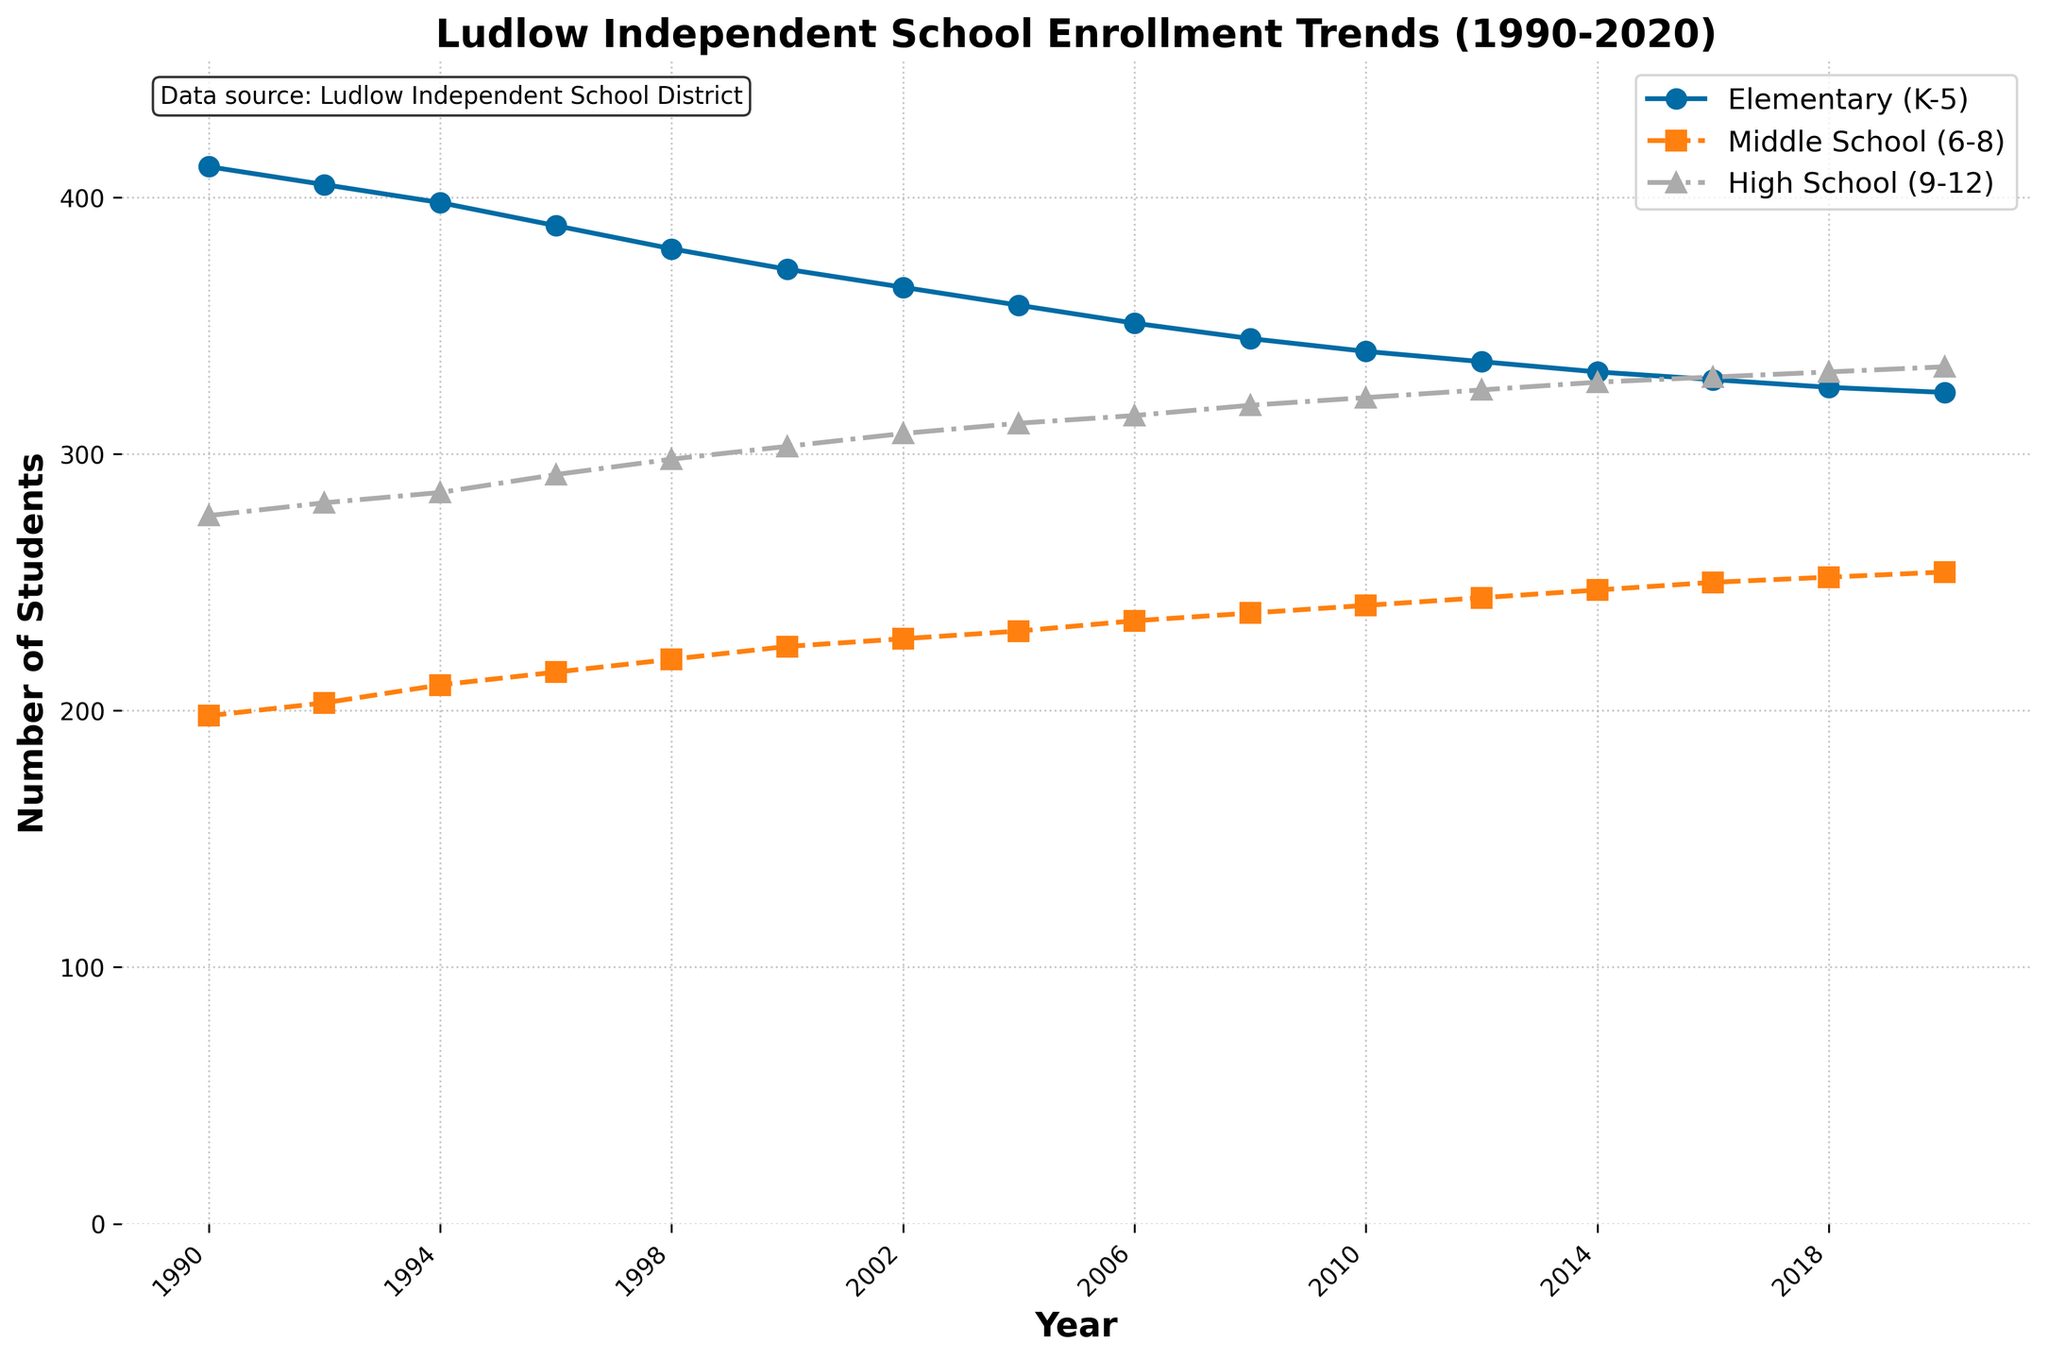What's the overall enrollment trend for elementary school students from 1990 to 2020? To identify the trend, observe the line for "Elementary (K-5)". Notice that the number of students consistently decreases from 412 in 1990 to 324 in 2020.
Answer: Downward Which grade level had the highest enrollment in 2020? Look at the three lines at the 2020 mark. The line for "High School (9-12)" is the highest, indicating it had the most students.
Answer: High School (9-12) In which year did middle school enrollment first surpass 240 students? Examine the "Middle School (6-8)" line and locate the first year it reaches above 240. This happens in 2010.
Answer: 2010 How does the enrollment of high school students in 2000 compare to that in 1990? Compare the data points for "High School (9-12)" in 2000 and 1990. There were 303 students in 2000 and 276 in 1990, showing an increase.
Answer: Increased Calculate the difference in elementary school enrollment between 1998 and 2020. Subtract the number of elementary students in 2020 (324) from the number in 1998 (380). The difference is 380 - 324 = 56.
Answer: 56 Between 2004 and 2008, which grade level saw the smallest change in enrollment? Calculate the enrollment differences: Elementary (358 to 345 = 13), Middle School (231 to 238 = 7), High School (312 to 319 = 7). Both Middle and High School have a change of 7, which is the smallest.
Answer: Middle School (6-8) and High School (9-12) What is the average high school enrollment for the decades 1990s and 2000s? Calculate the averages for the two decades by adding the enrollments and dividing by their counts. 
1990s: (276+281+285+292+298) / 5 = 286.4
2000s: (303+308+312+315+319) / 5 = 311.4
Answer: 1990s: 286.4, 2000s: 311.4 Which year had the highest overall total enrollment across all grade levels? Sum the enrollments for each year and compare. 1990 has the highest total (412 + 198 + 276 = 886).
Answer: 1990 How many years had more than 500 students enrolled in elementary and middle school combined? For each year, add the "Elementary (K-5)" and "Middle School (6-8)" values and count the years where the sum is over 500. The years are 1990, 1992, 1994, 1996, 1998 (5 years).
Answer: 5 years 